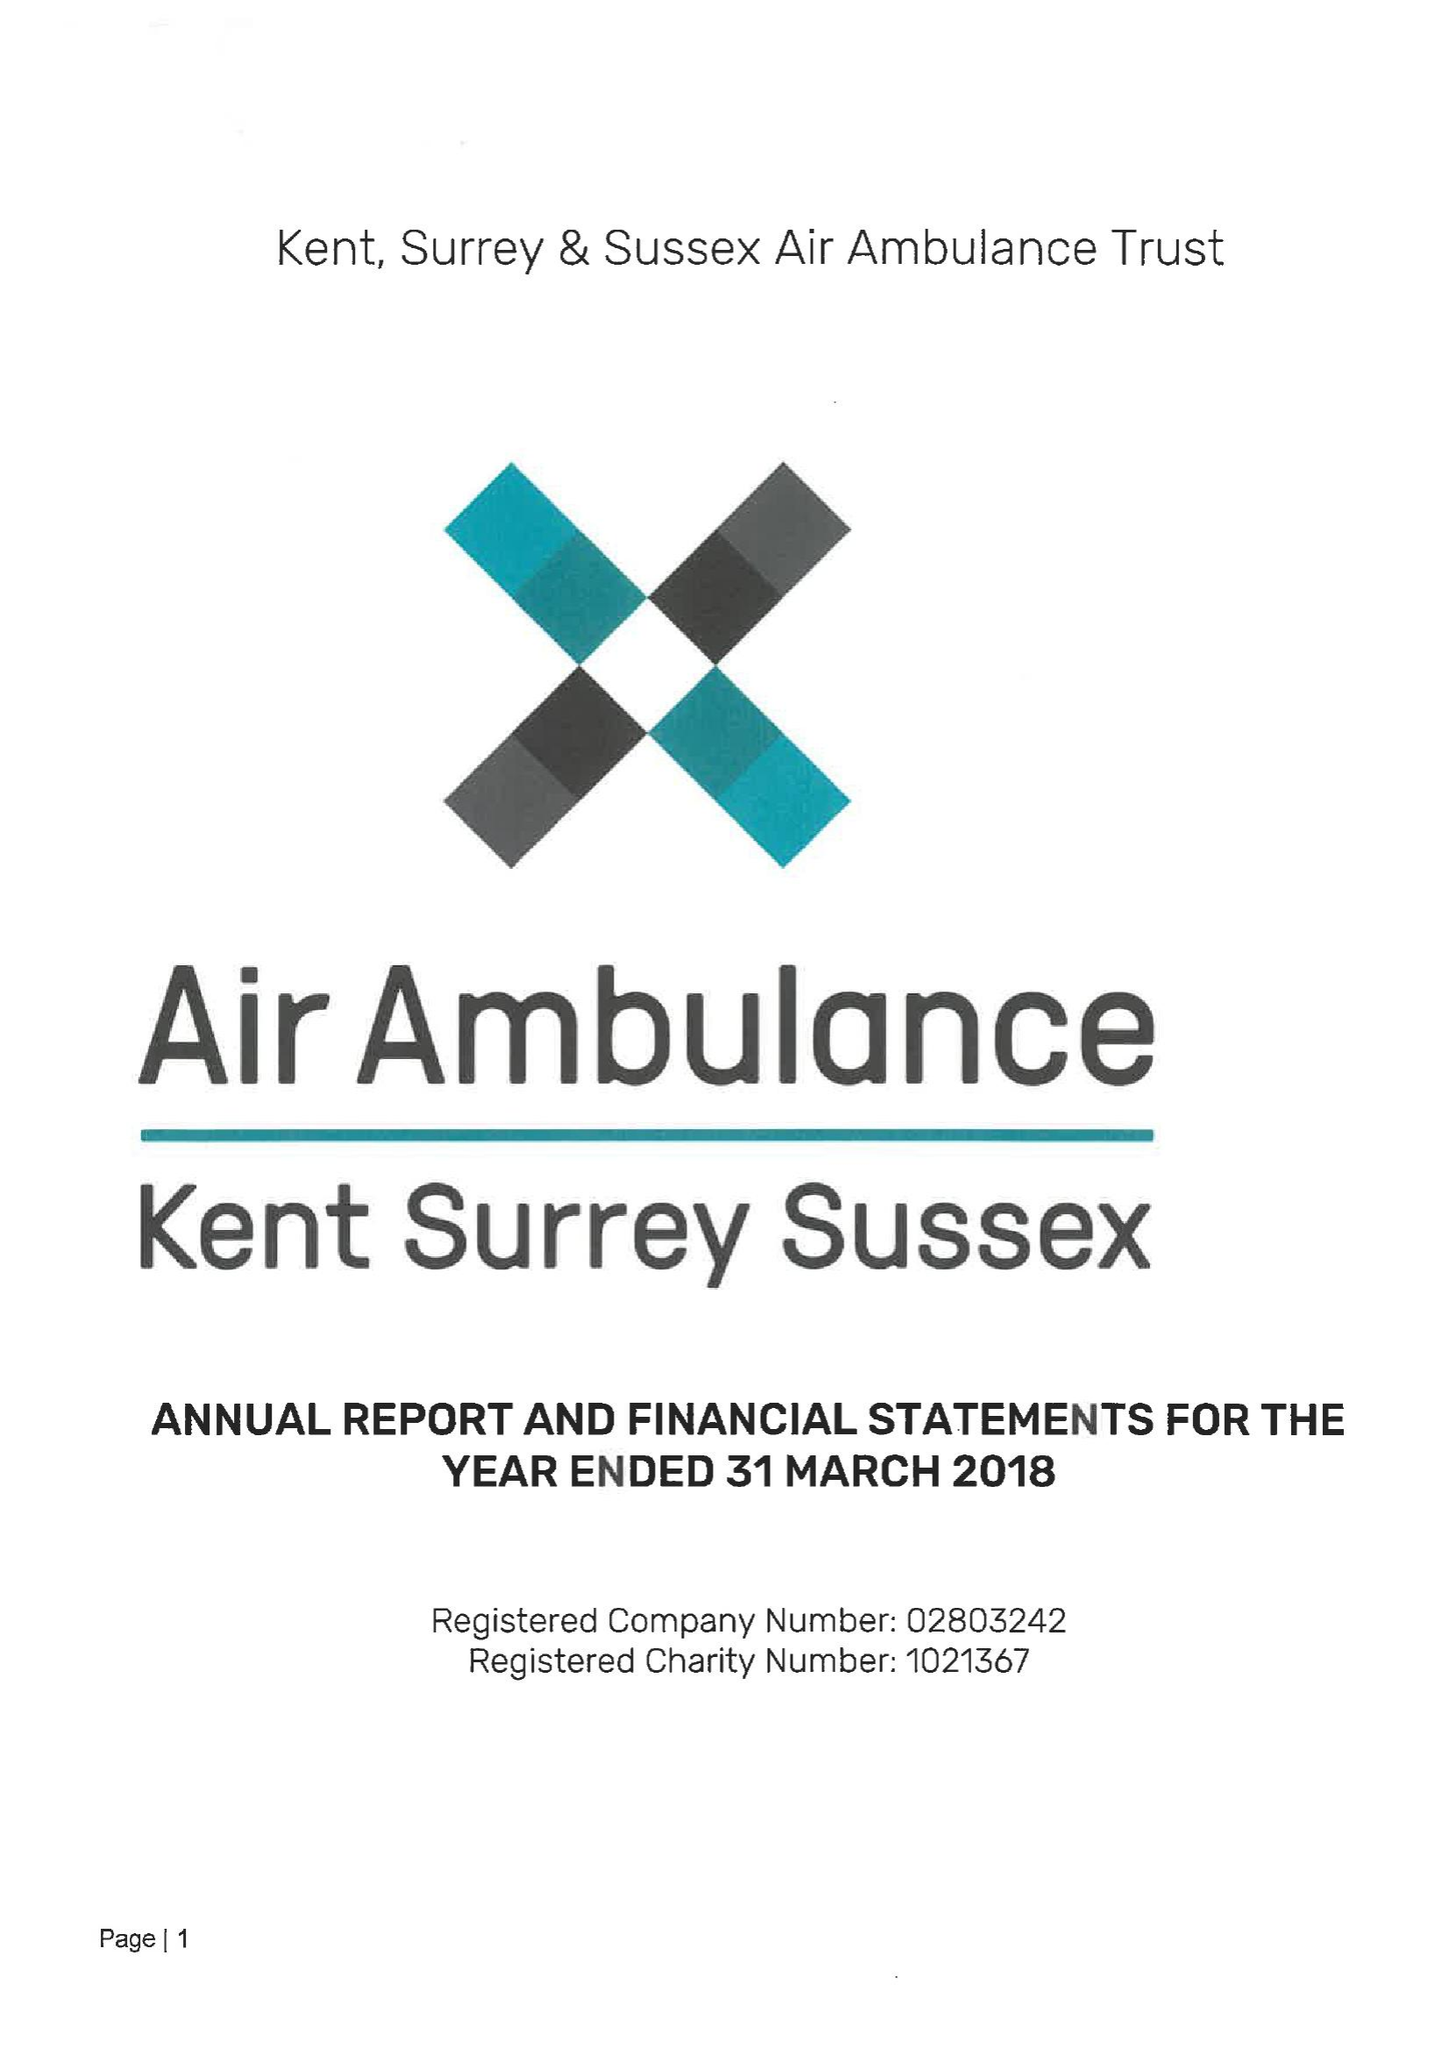What is the value for the spending_annually_in_british_pounds?
Answer the question using a single word or phrase. 10971574.00 